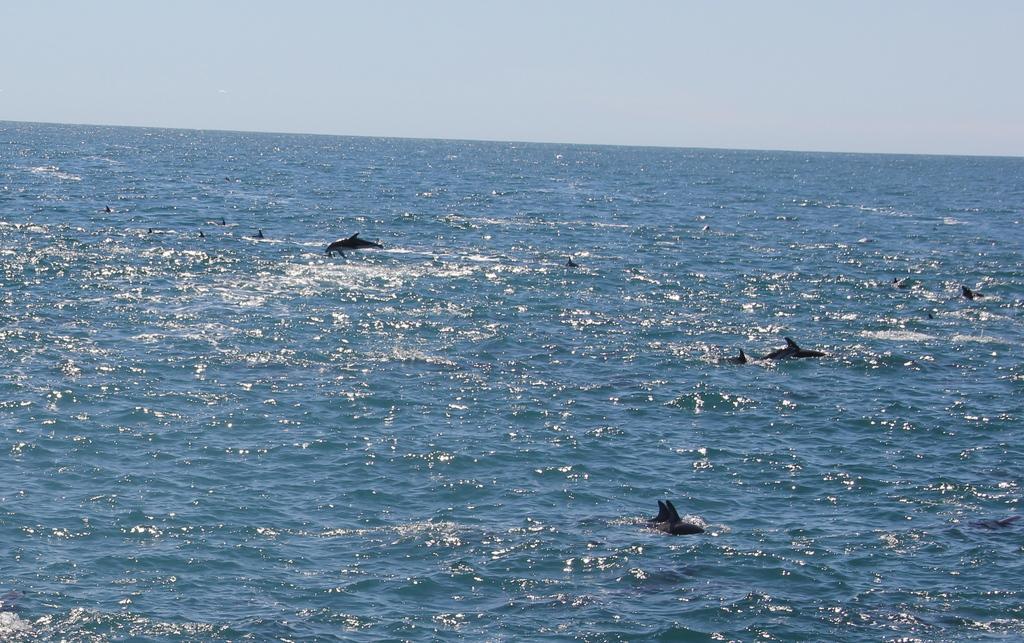Can you describe this image briefly? In this image, I can see the dolphins in the water. This looks like a sea. Here is a dolphin jumping. This is the sky. 